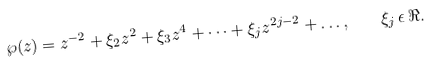<formula> <loc_0><loc_0><loc_500><loc_500>\wp ( z ) = z ^ { - 2 } + \xi _ { 2 } z ^ { 2 } + \xi _ { 3 } z ^ { 4 } + \dots + \xi _ { j } z ^ { 2 j - 2 } + \dots , \quad \xi _ { j } \, \epsilon \, \Re .</formula> 